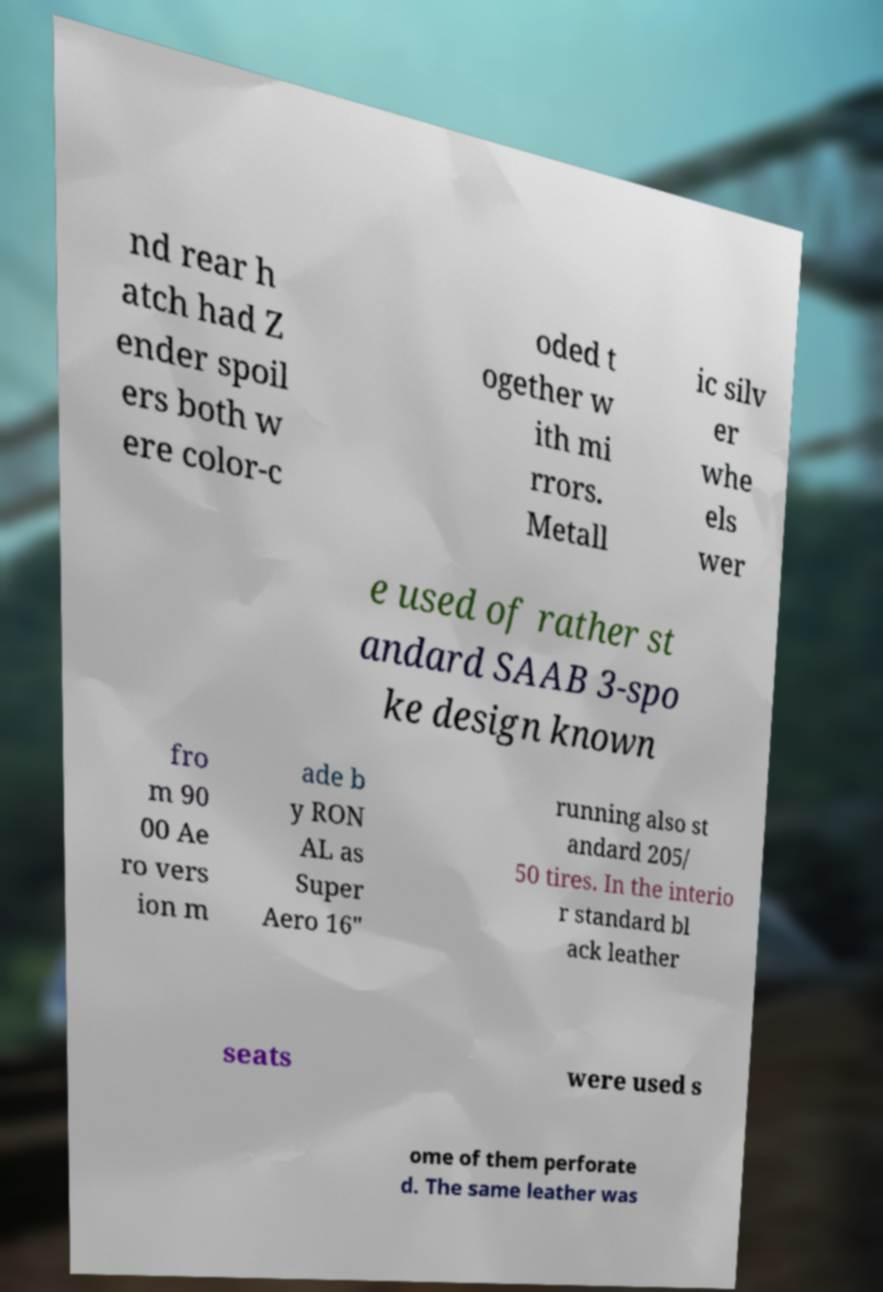Can you accurately transcribe the text from the provided image for me? nd rear h atch had Z ender spoil ers both w ere color-c oded t ogether w ith mi rrors. Metall ic silv er whe els wer e used of rather st andard SAAB 3-spo ke design known fro m 90 00 Ae ro vers ion m ade b y RON AL as Super Aero 16" running also st andard 205/ 50 tires. In the interio r standard bl ack leather seats were used s ome of them perforate d. The same leather was 